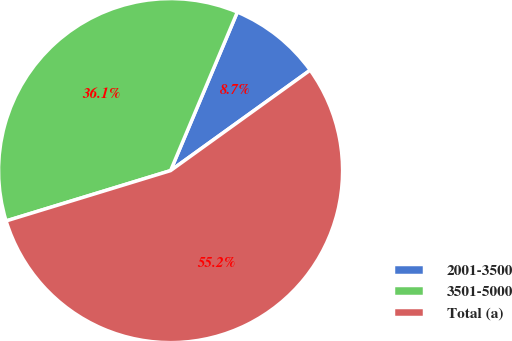<chart> <loc_0><loc_0><loc_500><loc_500><pie_chart><fcel>2001-3500<fcel>3501-5000<fcel>Total (a)<nl><fcel>8.73%<fcel>36.07%<fcel>55.2%<nl></chart> 